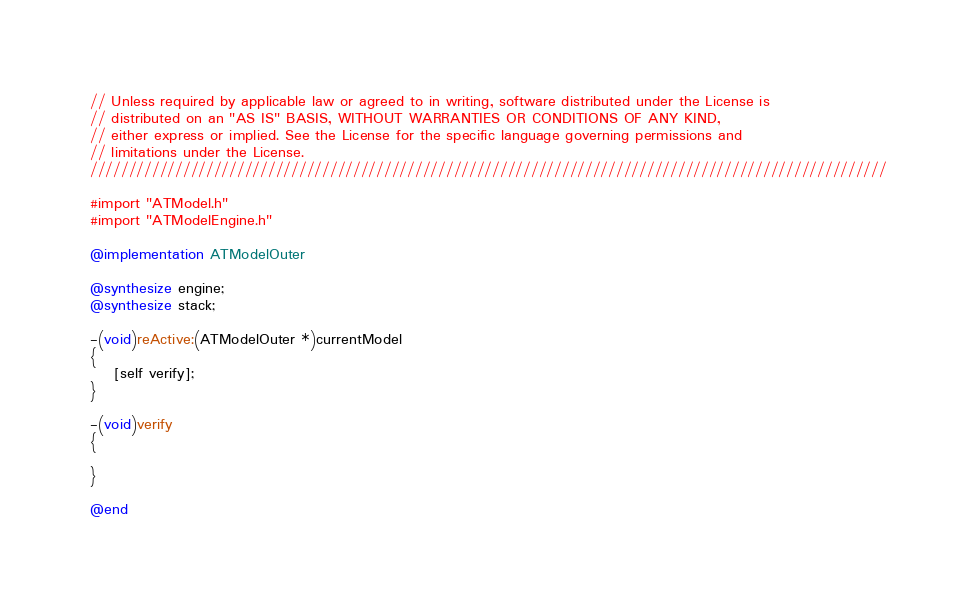<code> <loc_0><loc_0><loc_500><loc_500><_ObjectiveC_>// Unless required by applicable law or agreed to in writing, software distributed under the License is
// distributed on an "AS IS" BASIS, WITHOUT WARRANTIES OR CONDITIONS OF ANY KIND,
// either express or implied. See the License for the specific language governing permissions and
// limitations under the License.
///////////////////////////////////////////////////////////////////////////////////////////////////////

#import "ATModel.h"
#import "ATModelEngine.h"

@implementation ATModelOuter

@synthesize engine;
@synthesize stack;

-(void)reActive:(ATModelOuter *)currentModel
{
    [self verify];
}

-(void)verify
{

}

@end
</code> 